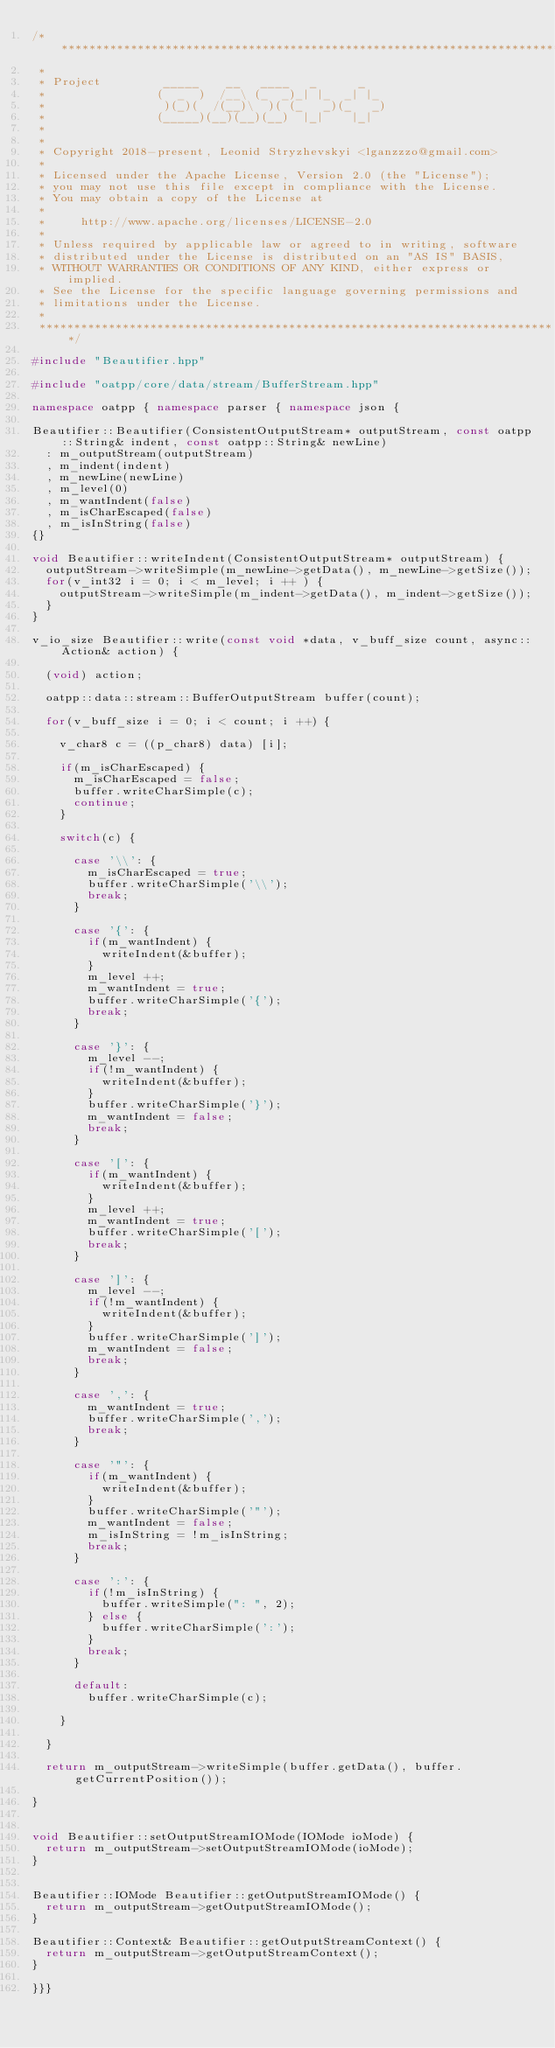<code> <loc_0><loc_0><loc_500><loc_500><_C++_>/***************************************************************************
 *
 * Project         _____    __   ____   _      _
 *                (  _  )  /__\ (_  _)_| |_  _| |_
 *                 )(_)(  /(__)\  )( (_   _)(_   _)
 *                (_____)(__)(__)(__)  |_|    |_|
 *
 *
 * Copyright 2018-present, Leonid Stryzhevskyi <lganzzzo@gmail.com>
 *
 * Licensed under the Apache License, Version 2.0 (the "License");
 * you may not use this file except in compliance with the License.
 * You may obtain a copy of the License at
 *
 *     http://www.apache.org/licenses/LICENSE-2.0
 *
 * Unless required by applicable law or agreed to in writing, software
 * distributed under the License is distributed on an "AS IS" BASIS,
 * WITHOUT WARRANTIES OR CONDITIONS OF ANY KIND, either express or implied.
 * See the License for the specific language governing permissions and
 * limitations under the License.
 *
 ***************************************************************************/

#include "Beautifier.hpp"

#include "oatpp/core/data/stream/BufferStream.hpp"

namespace oatpp { namespace parser { namespace json {

Beautifier::Beautifier(ConsistentOutputStream* outputStream, const oatpp::String& indent, const oatpp::String& newLine)
  : m_outputStream(outputStream)
  , m_indent(indent)
  , m_newLine(newLine)
  , m_level(0)
  , m_wantIndent(false)
  , m_isCharEscaped(false)
  , m_isInString(false)
{}

void Beautifier::writeIndent(ConsistentOutputStream* outputStream) {
  outputStream->writeSimple(m_newLine->getData(), m_newLine->getSize());
  for(v_int32 i = 0; i < m_level; i ++ ) {
    outputStream->writeSimple(m_indent->getData(), m_indent->getSize());
  }
}

v_io_size Beautifier::write(const void *data, v_buff_size count, async::Action& action) {

  (void) action;

  oatpp::data::stream::BufferOutputStream buffer(count);

  for(v_buff_size i = 0; i < count; i ++) {

    v_char8 c = ((p_char8) data) [i];

    if(m_isCharEscaped) {
      m_isCharEscaped = false;
      buffer.writeCharSimple(c);
      continue;
    }

    switch(c) {

      case '\\': {
        m_isCharEscaped = true;
        buffer.writeCharSimple('\\');
        break;
      }

      case '{': {
        if(m_wantIndent) {
          writeIndent(&buffer);
        }
        m_level ++;
        m_wantIndent = true;
        buffer.writeCharSimple('{');
        break;
      }

      case '}': {
        m_level --;
        if(!m_wantIndent) {
          writeIndent(&buffer);
        }
        buffer.writeCharSimple('}');
        m_wantIndent = false;
        break;
      }

      case '[': {
        if(m_wantIndent) {
          writeIndent(&buffer);
        }
        m_level ++;
        m_wantIndent = true;
        buffer.writeCharSimple('[');
        break;
      }

      case ']': {
        m_level --;
        if(!m_wantIndent) {
          writeIndent(&buffer);
        }
        buffer.writeCharSimple(']');
        m_wantIndent = false;
        break;
      }

      case ',': {
        m_wantIndent = true;
        buffer.writeCharSimple(',');
        break;
      }

      case '"': {
        if(m_wantIndent) {
          writeIndent(&buffer);
        }
        buffer.writeCharSimple('"');
        m_wantIndent = false;
        m_isInString = !m_isInString;
        break;
      }

      case ':': {
        if(!m_isInString) {
          buffer.writeSimple(": ", 2);
        } else {
          buffer.writeCharSimple(':');
        }
        break;
      }

      default:
        buffer.writeCharSimple(c);

    }

  }

  return m_outputStream->writeSimple(buffer.getData(), buffer.getCurrentPosition());

}


void Beautifier::setOutputStreamIOMode(IOMode ioMode) {
  return m_outputStream->setOutputStreamIOMode(ioMode);
}


Beautifier::IOMode Beautifier::getOutputStreamIOMode() {
  return m_outputStream->getOutputStreamIOMode();
}

Beautifier::Context& Beautifier::getOutputStreamContext() {
  return m_outputStream->getOutputStreamContext();
}

}}}
</code> 